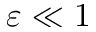Convert formula to latex. <formula><loc_0><loc_0><loc_500><loc_500>\varepsilon \ll 1</formula> 